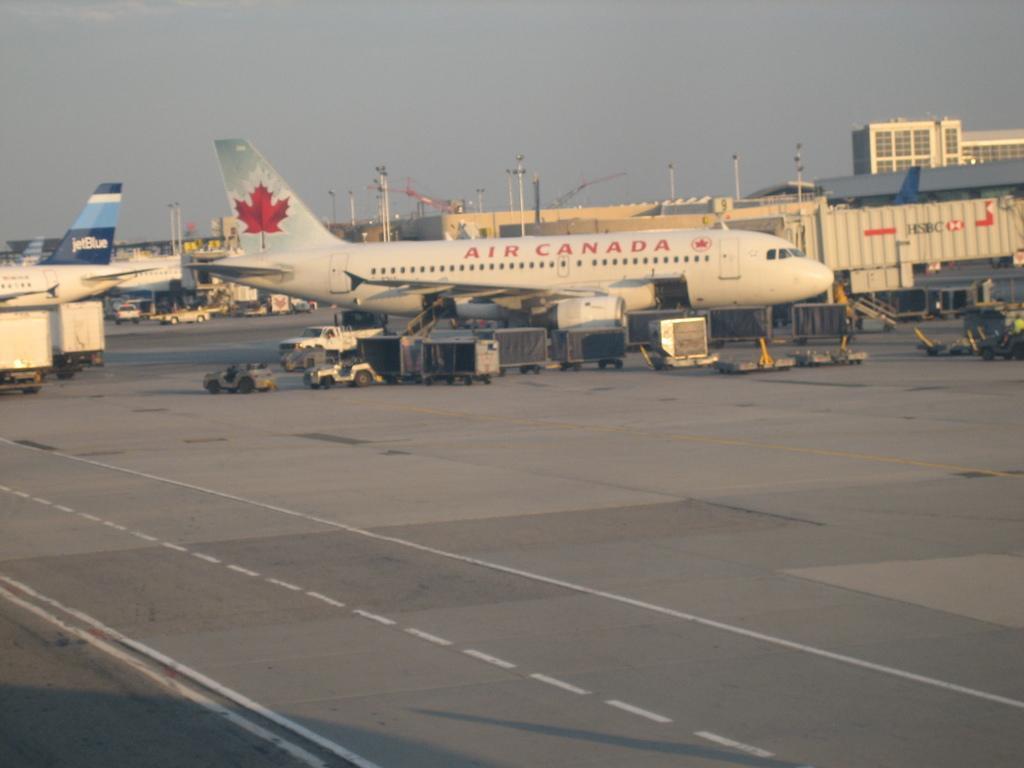How would you summarize this image in a sentence or two? In this image, I can see aircrafts on the road and fleets of vehicles. In the background, I can see buildings, light poles and the sky. This image might be taken in a day. 